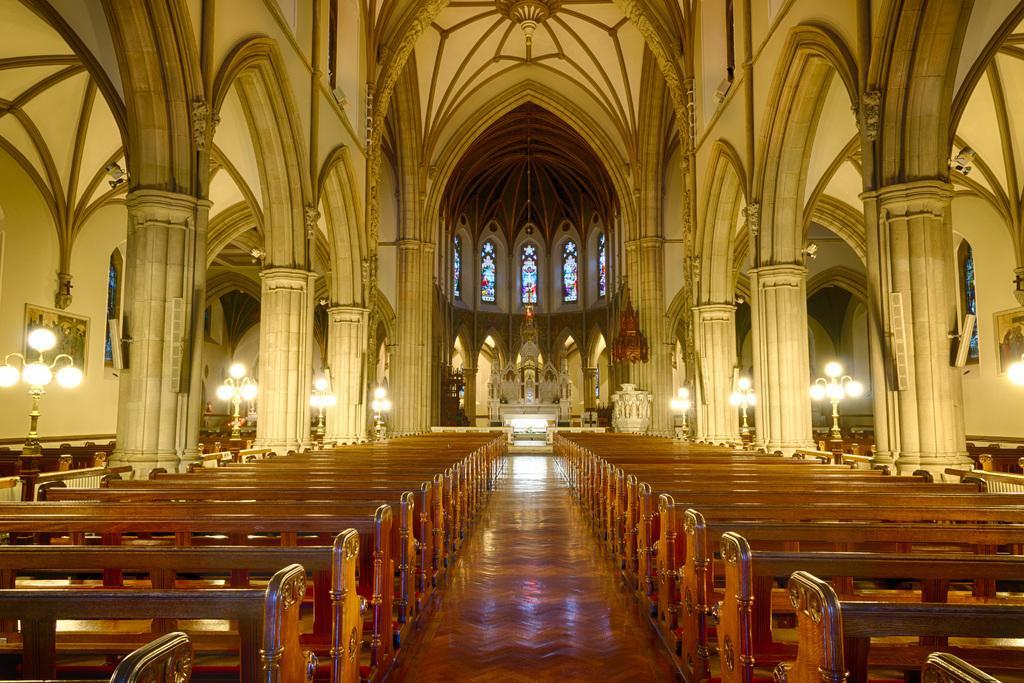Describe this image in one or two sentences. This picture is clicked inside the hall. In the foreground we can see the benches, lamps, pillars and windows. In the background we can see the chandelier, windows, roof and some other objects, we can see the picture frames hanging on the wall. 